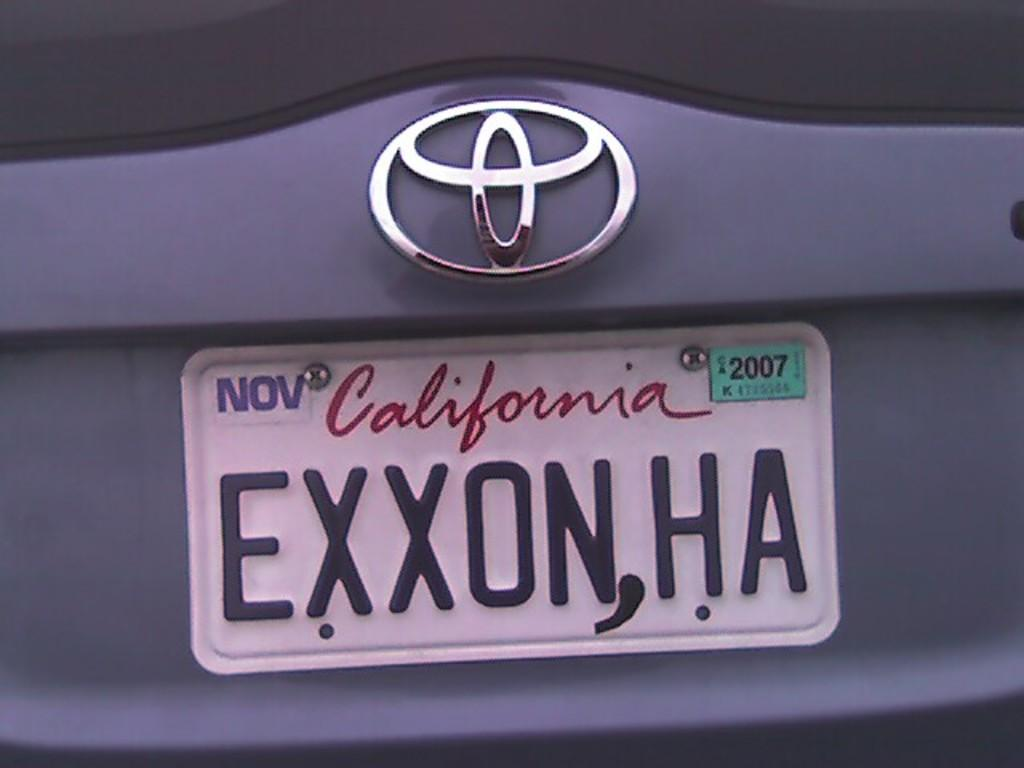<image>
Summarize the visual content of the image. A Toyota with a license plate tagged in California with a registration expiring in November. 